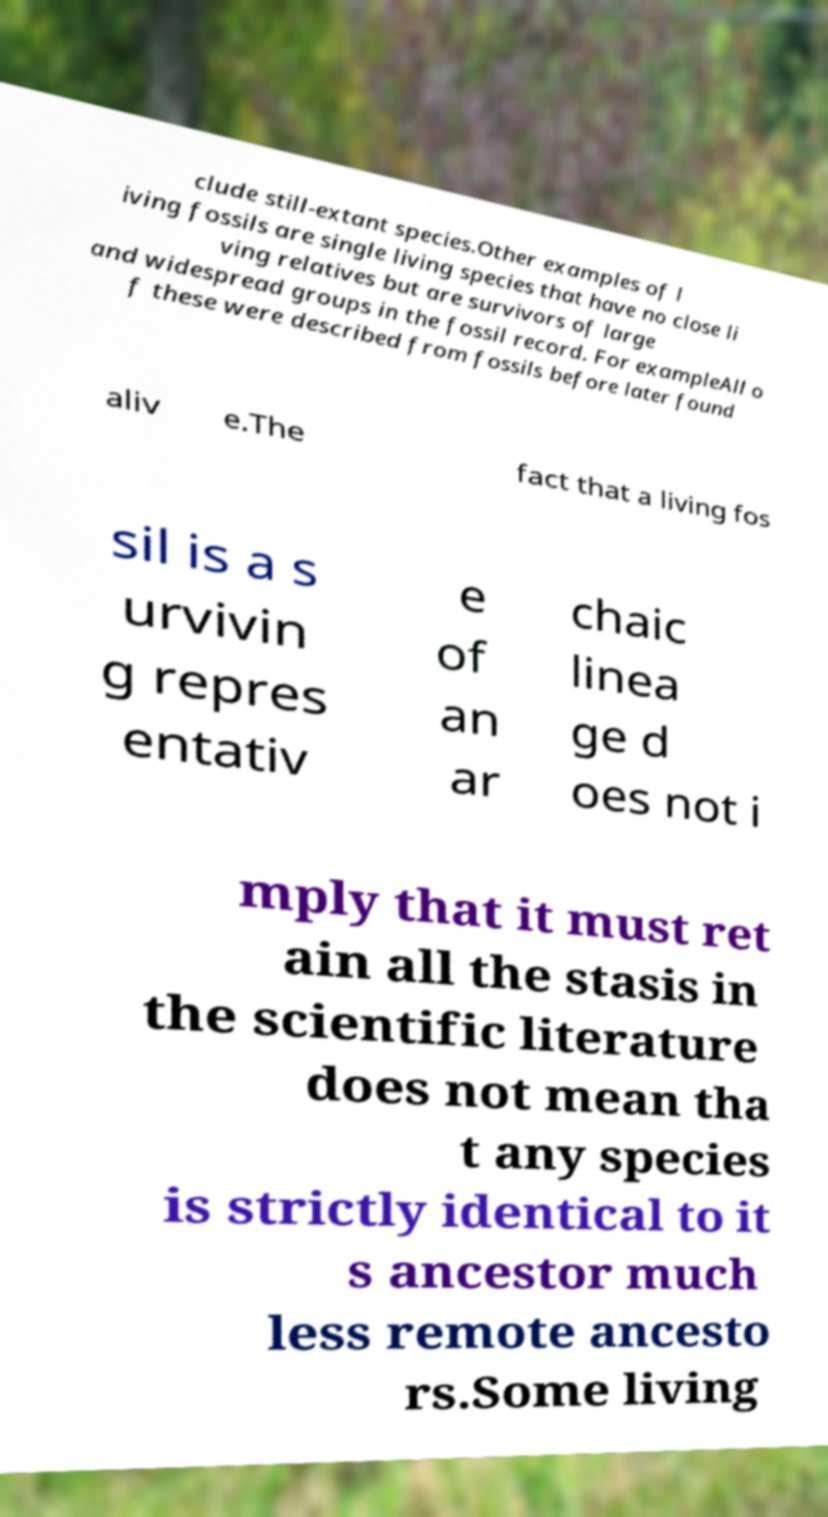I need the written content from this picture converted into text. Can you do that? clude still-extant species.Other examples of l iving fossils are single living species that have no close li ving relatives but are survivors of large and widespread groups in the fossil record. For exampleAll o f these were described from fossils before later found aliv e.The fact that a living fos sil is a s urvivin g repres entativ e of an ar chaic linea ge d oes not i mply that it must ret ain all the stasis in the scientific literature does not mean tha t any species is strictly identical to it s ancestor much less remote ancesto rs.Some living 